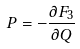<formula> <loc_0><loc_0><loc_500><loc_500>P = - \frac { \partial F _ { 3 } } { \partial Q }</formula> 